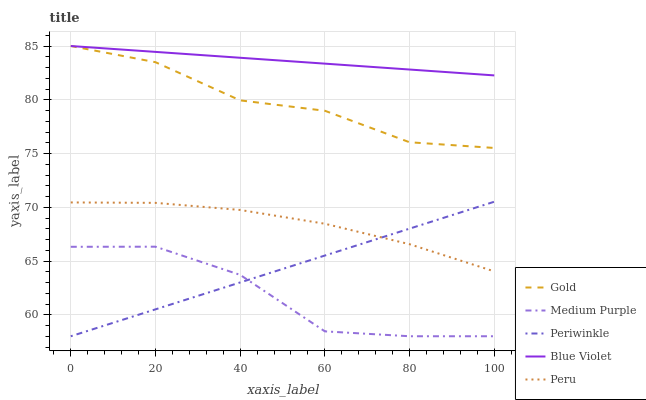Does Peru have the minimum area under the curve?
Answer yes or no. No. Does Peru have the maximum area under the curve?
Answer yes or no. No. Is Peru the smoothest?
Answer yes or no. No. Is Peru the roughest?
Answer yes or no. No. Does Peru have the lowest value?
Answer yes or no. No. Does Peru have the highest value?
Answer yes or no. No. Is Periwinkle less than Gold?
Answer yes or no. Yes. Is Blue Violet greater than Peru?
Answer yes or no. Yes. Does Periwinkle intersect Gold?
Answer yes or no. No. 